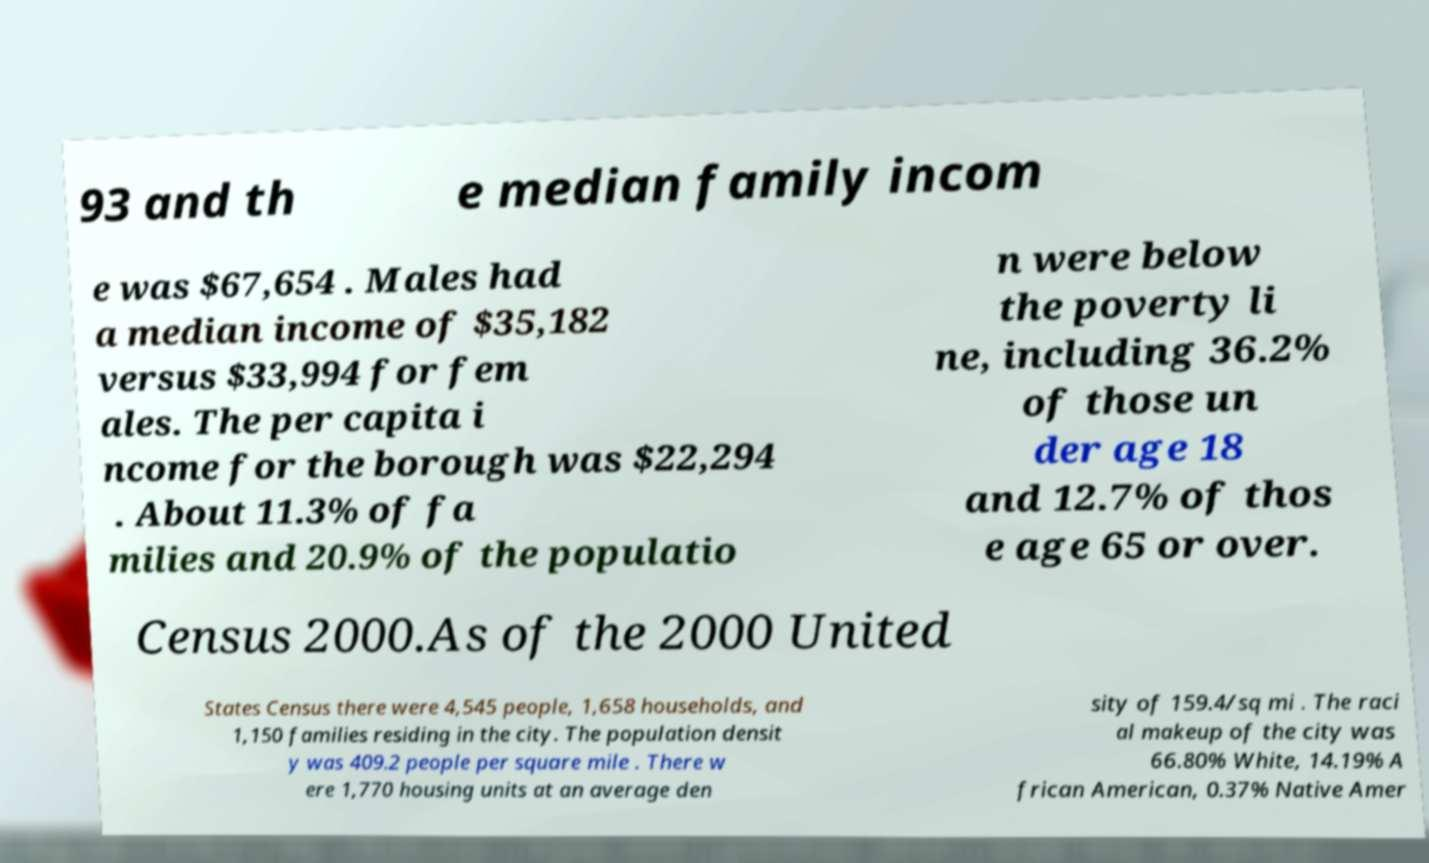What messages or text are displayed in this image? I need them in a readable, typed format. 93 and th e median family incom e was $67,654 . Males had a median income of $35,182 versus $33,994 for fem ales. The per capita i ncome for the borough was $22,294 . About 11.3% of fa milies and 20.9% of the populatio n were below the poverty li ne, including 36.2% of those un der age 18 and 12.7% of thos e age 65 or over. Census 2000.As of the 2000 United States Census there were 4,545 people, 1,658 households, and 1,150 families residing in the city. The population densit y was 409.2 people per square mile . There w ere 1,770 housing units at an average den sity of 159.4/sq mi . The raci al makeup of the city was 66.80% White, 14.19% A frican American, 0.37% Native Amer 